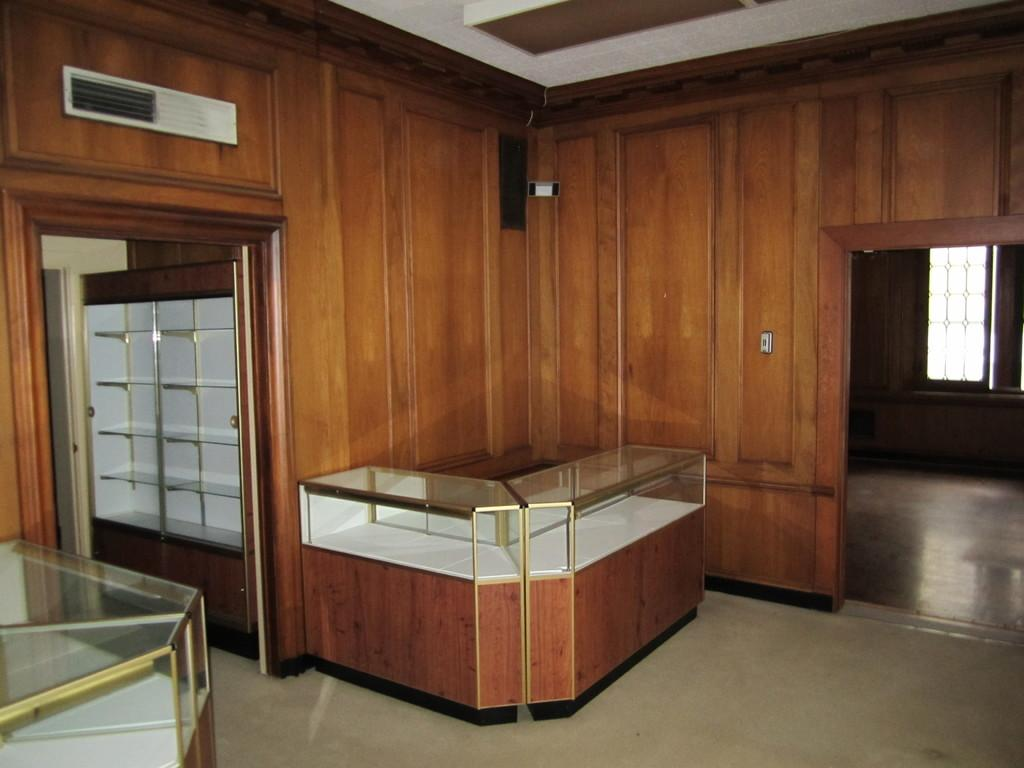What type of view does the image provide? The image shows an inner view of a room. What can be found on the walls of the room? There are shelves in the room. What material is used for the walls in the room? The wall in the room is made of wood. What is present on the wall in the room? There is a board in the room. How is natural light introduced into the room? There is a window in the room. What covers the room to protect it from the elements? The room has a roof. What type of suggestion is written on the board in the room? There is no suggestion written on the board in the room; the board is not described as having any writing or text. 